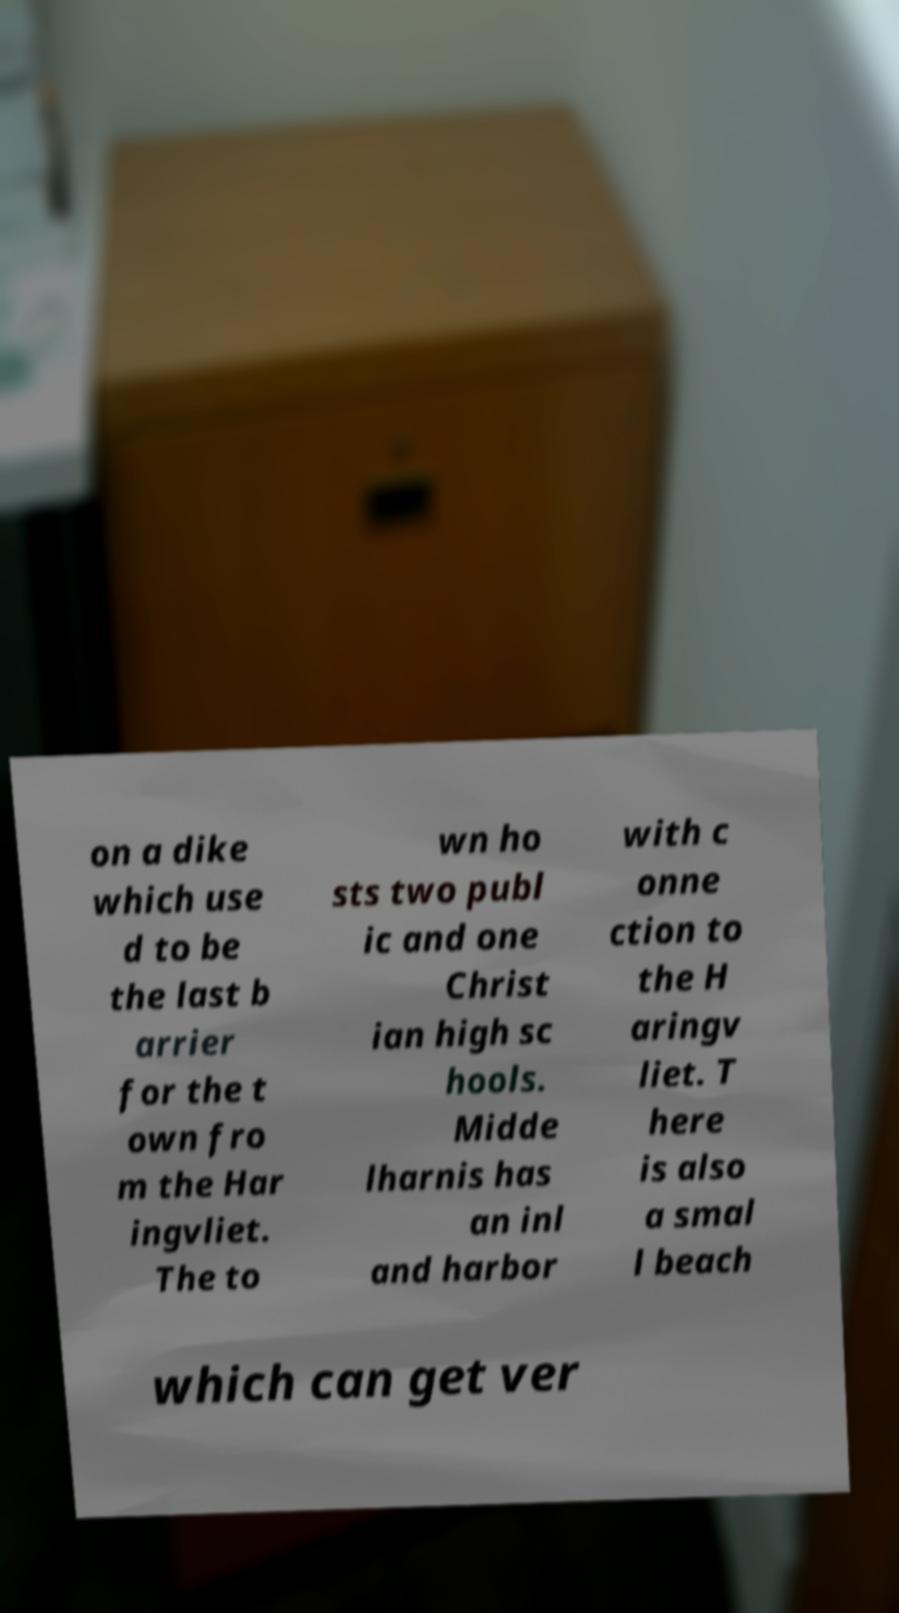Could you assist in decoding the text presented in this image and type it out clearly? on a dike which use d to be the last b arrier for the t own fro m the Har ingvliet. The to wn ho sts two publ ic and one Christ ian high sc hools. Midde lharnis has an inl and harbor with c onne ction to the H aringv liet. T here is also a smal l beach which can get ver 